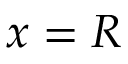Convert formula to latex. <formula><loc_0><loc_0><loc_500><loc_500>x = R</formula> 